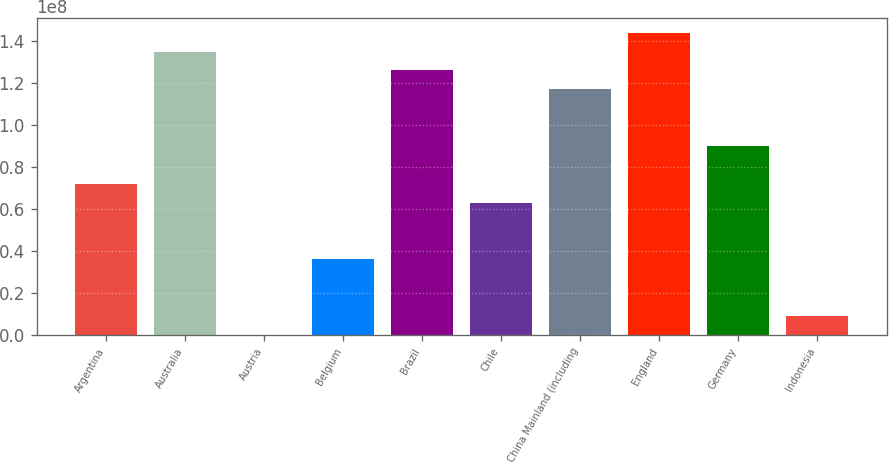Convert chart to OTSL. <chart><loc_0><loc_0><loc_500><loc_500><bar_chart><fcel>Argentina<fcel>Australia<fcel>Austria<fcel>Belgium<fcel>Brazil<fcel>Chile<fcel>China Mainland (including<fcel>England<fcel>Germany<fcel>Indonesia<nl><fcel>7.1908e+07<fcel>1.34798e+08<fcel>33300<fcel>3.59706e+07<fcel>1.25814e+08<fcel>6.29236e+07<fcel>1.1683e+08<fcel>1.43783e+08<fcel>8.98766e+07<fcel>9.01763e+06<nl></chart> 